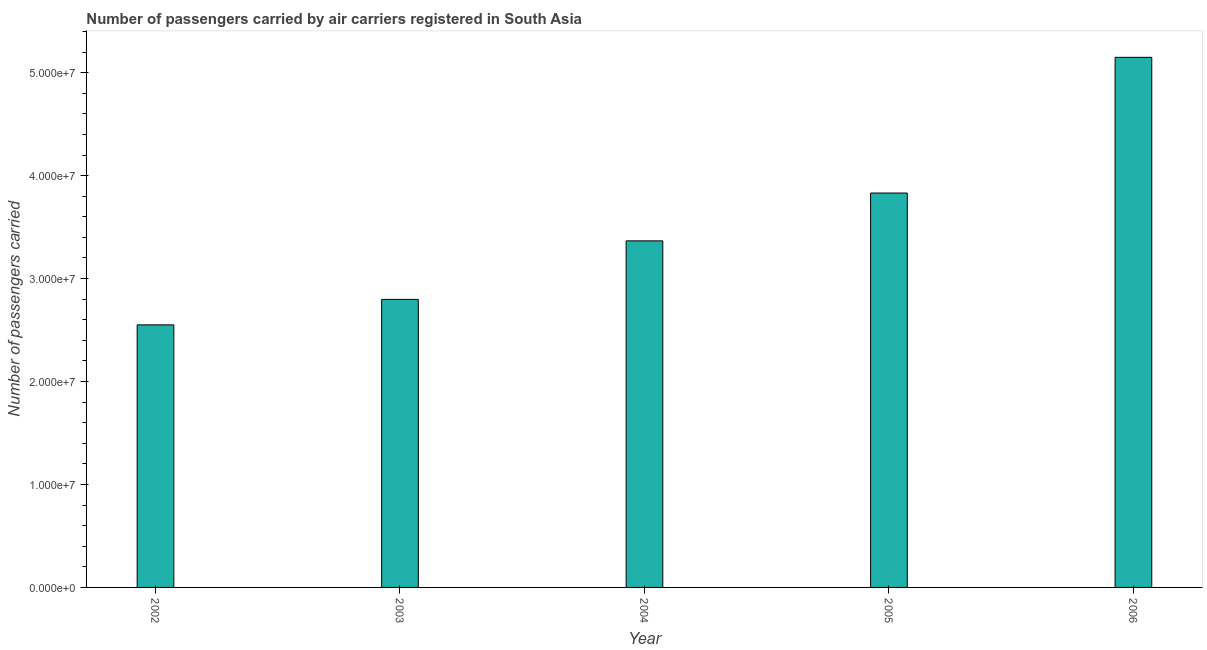What is the title of the graph?
Offer a terse response. Number of passengers carried by air carriers registered in South Asia. What is the label or title of the X-axis?
Your response must be concise. Year. What is the label or title of the Y-axis?
Keep it short and to the point. Number of passengers carried. What is the number of passengers carried in 2002?
Offer a very short reply. 2.55e+07. Across all years, what is the maximum number of passengers carried?
Provide a short and direct response. 5.15e+07. Across all years, what is the minimum number of passengers carried?
Offer a terse response. 2.55e+07. What is the sum of the number of passengers carried?
Give a very brief answer. 1.77e+08. What is the difference between the number of passengers carried in 2003 and 2006?
Make the answer very short. -2.35e+07. What is the average number of passengers carried per year?
Give a very brief answer. 3.54e+07. What is the median number of passengers carried?
Your response must be concise. 3.37e+07. In how many years, is the number of passengers carried greater than 28000000 ?
Provide a succinct answer. 3. What is the ratio of the number of passengers carried in 2003 to that in 2004?
Your answer should be very brief. 0.83. Is the difference between the number of passengers carried in 2005 and 2006 greater than the difference between any two years?
Provide a short and direct response. No. What is the difference between the highest and the second highest number of passengers carried?
Your answer should be compact. 1.32e+07. Is the sum of the number of passengers carried in 2003 and 2004 greater than the maximum number of passengers carried across all years?
Offer a very short reply. Yes. What is the difference between the highest and the lowest number of passengers carried?
Ensure brevity in your answer.  2.60e+07. Are all the bars in the graph horizontal?
Provide a short and direct response. No. What is the difference between two consecutive major ticks on the Y-axis?
Offer a very short reply. 1.00e+07. What is the Number of passengers carried of 2002?
Offer a terse response. 2.55e+07. What is the Number of passengers carried in 2003?
Your response must be concise. 2.80e+07. What is the Number of passengers carried of 2004?
Offer a very short reply. 3.37e+07. What is the Number of passengers carried of 2005?
Offer a terse response. 3.83e+07. What is the Number of passengers carried in 2006?
Give a very brief answer. 5.15e+07. What is the difference between the Number of passengers carried in 2002 and 2003?
Make the answer very short. -2.47e+06. What is the difference between the Number of passengers carried in 2002 and 2004?
Make the answer very short. -8.16e+06. What is the difference between the Number of passengers carried in 2002 and 2005?
Ensure brevity in your answer.  -1.28e+07. What is the difference between the Number of passengers carried in 2002 and 2006?
Make the answer very short. -2.60e+07. What is the difference between the Number of passengers carried in 2003 and 2004?
Offer a terse response. -5.69e+06. What is the difference between the Number of passengers carried in 2003 and 2005?
Your response must be concise. -1.03e+07. What is the difference between the Number of passengers carried in 2003 and 2006?
Make the answer very short. -2.35e+07. What is the difference between the Number of passengers carried in 2004 and 2005?
Provide a short and direct response. -4.65e+06. What is the difference between the Number of passengers carried in 2004 and 2006?
Ensure brevity in your answer.  -1.78e+07. What is the difference between the Number of passengers carried in 2005 and 2006?
Your answer should be compact. -1.32e+07. What is the ratio of the Number of passengers carried in 2002 to that in 2003?
Make the answer very short. 0.91. What is the ratio of the Number of passengers carried in 2002 to that in 2004?
Provide a short and direct response. 0.76. What is the ratio of the Number of passengers carried in 2002 to that in 2005?
Your answer should be very brief. 0.67. What is the ratio of the Number of passengers carried in 2002 to that in 2006?
Make the answer very short. 0.49. What is the ratio of the Number of passengers carried in 2003 to that in 2004?
Ensure brevity in your answer.  0.83. What is the ratio of the Number of passengers carried in 2003 to that in 2005?
Offer a terse response. 0.73. What is the ratio of the Number of passengers carried in 2003 to that in 2006?
Give a very brief answer. 0.54. What is the ratio of the Number of passengers carried in 2004 to that in 2005?
Offer a very short reply. 0.88. What is the ratio of the Number of passengers carried in 2004 to that in 2006?
Your response must be concise. 0.65. What is the ratio of the Number of passengers carried in 2005 to that in 2006?
Make the answer very short. 0.74. 